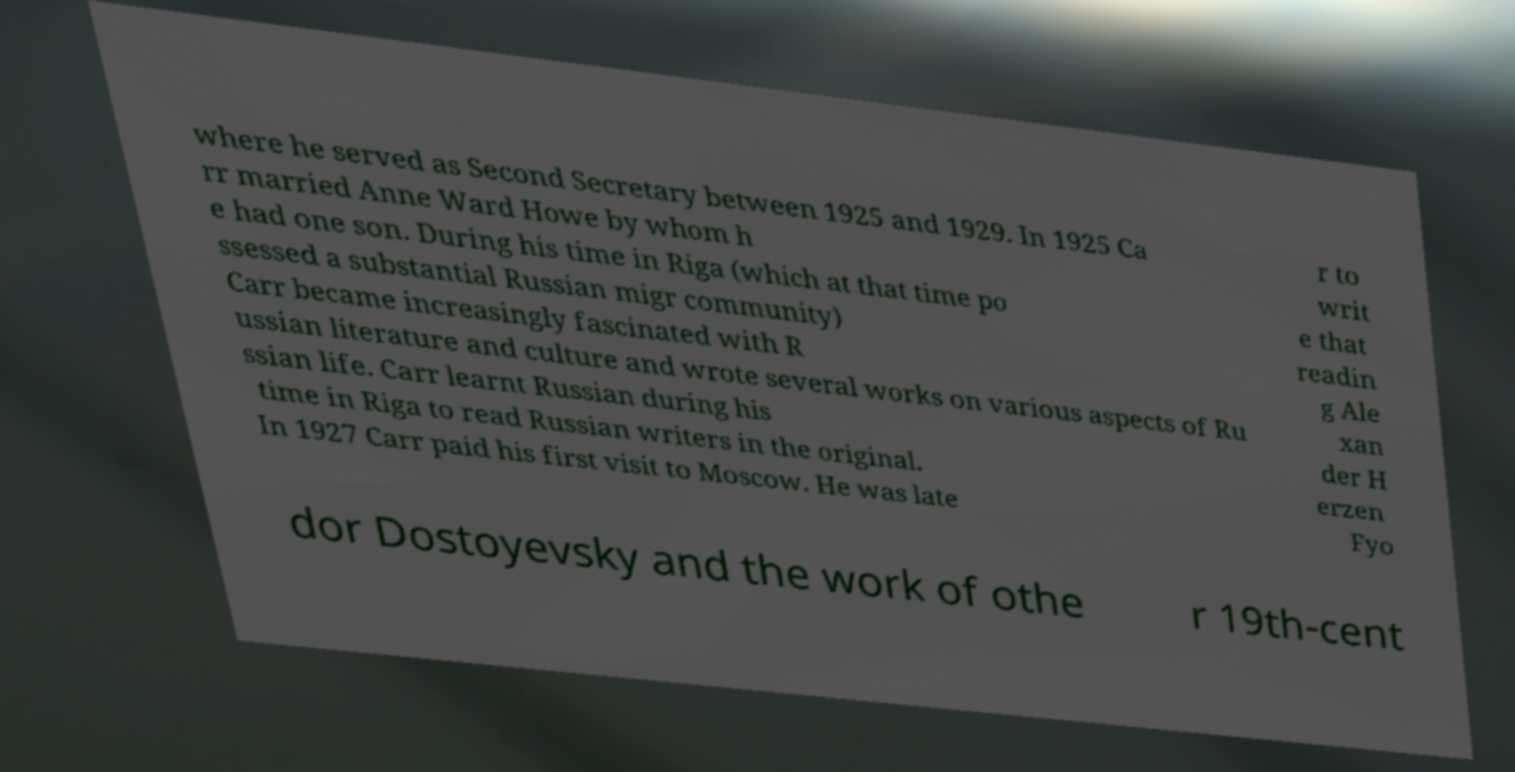Could you assist in decoding the text presented in this image and type it out clearly? where he served as Second Secretary between 1925 and 1929. In 1925 Ca rr married Anne Ward Howe by whom h e had one son. During his time in Riga (which at that time po ssessed a substantial Russian migr community) Carr became increasingly fascinated with R ussian literature and culture and wrote several works on various aspects of Ru ssian life. Carr learnt Russian during his time in Riga to read Russian writers in the original. In 1927 Carr paid his first visit to Moscow. He was late r to writ e that readin g Ale xan der H erzen Fyo dor Dostoyevsky and the work of othe r 19th-cent 